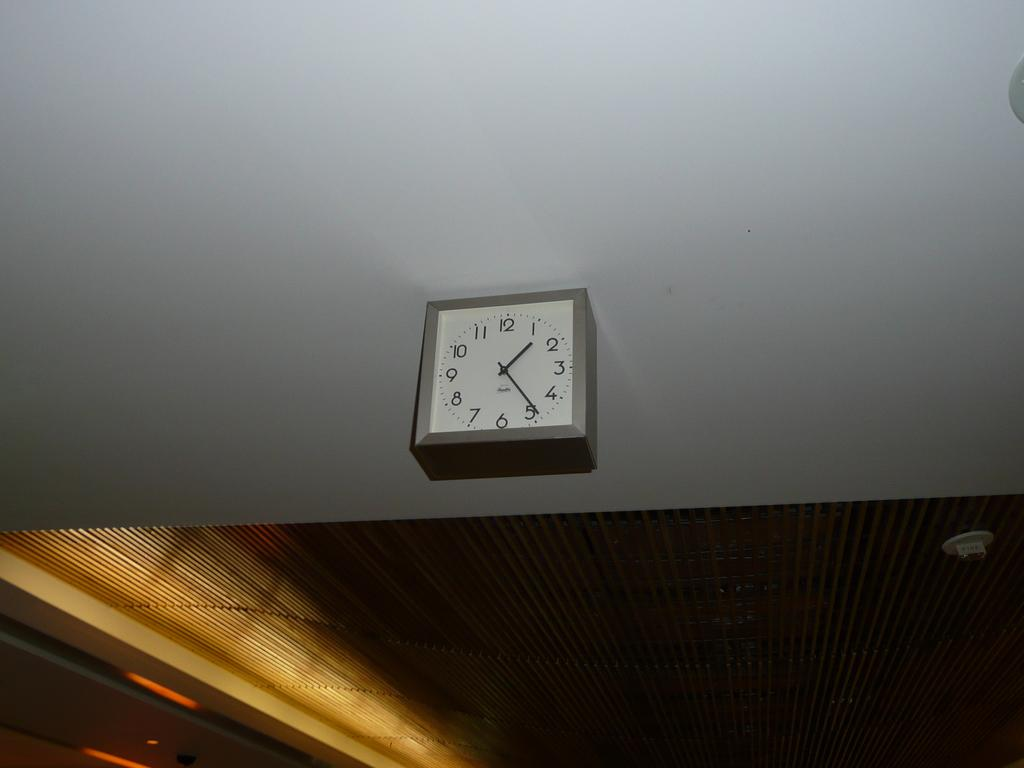<image>
Summarize the visual content of the image. A square clock that shows it to be 1:25. 